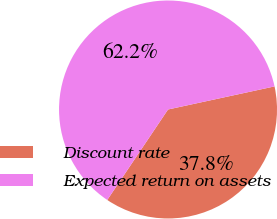<chart> <loc_0><loc_0><loc_500><loc_500><pie_chart><fcel>Discount rate<fcel>Expected return on assets<nl><fcel>37.81%<fcel>62.19%<nl></chart> 